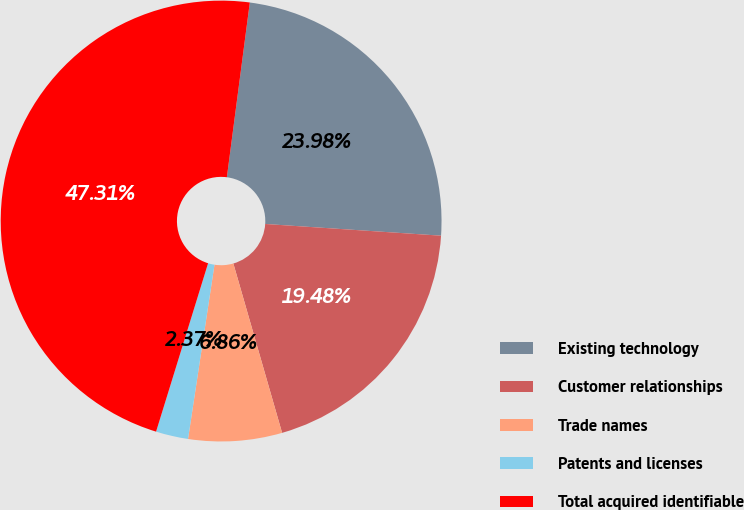Convert chart. <chart><loc_0><loc_0><loc_500><loc_500><pie_chart><fcel>Existing technology<fcel>Customer relationships<fcel>Trade names<fcel>Patents and licenses<fcel>Total acquired identifiable<nl><fcel>23.98%<fcel>19.48%<fcel>6.86%<fcel>2.37%<fcel>47.31%<nl></chart> 